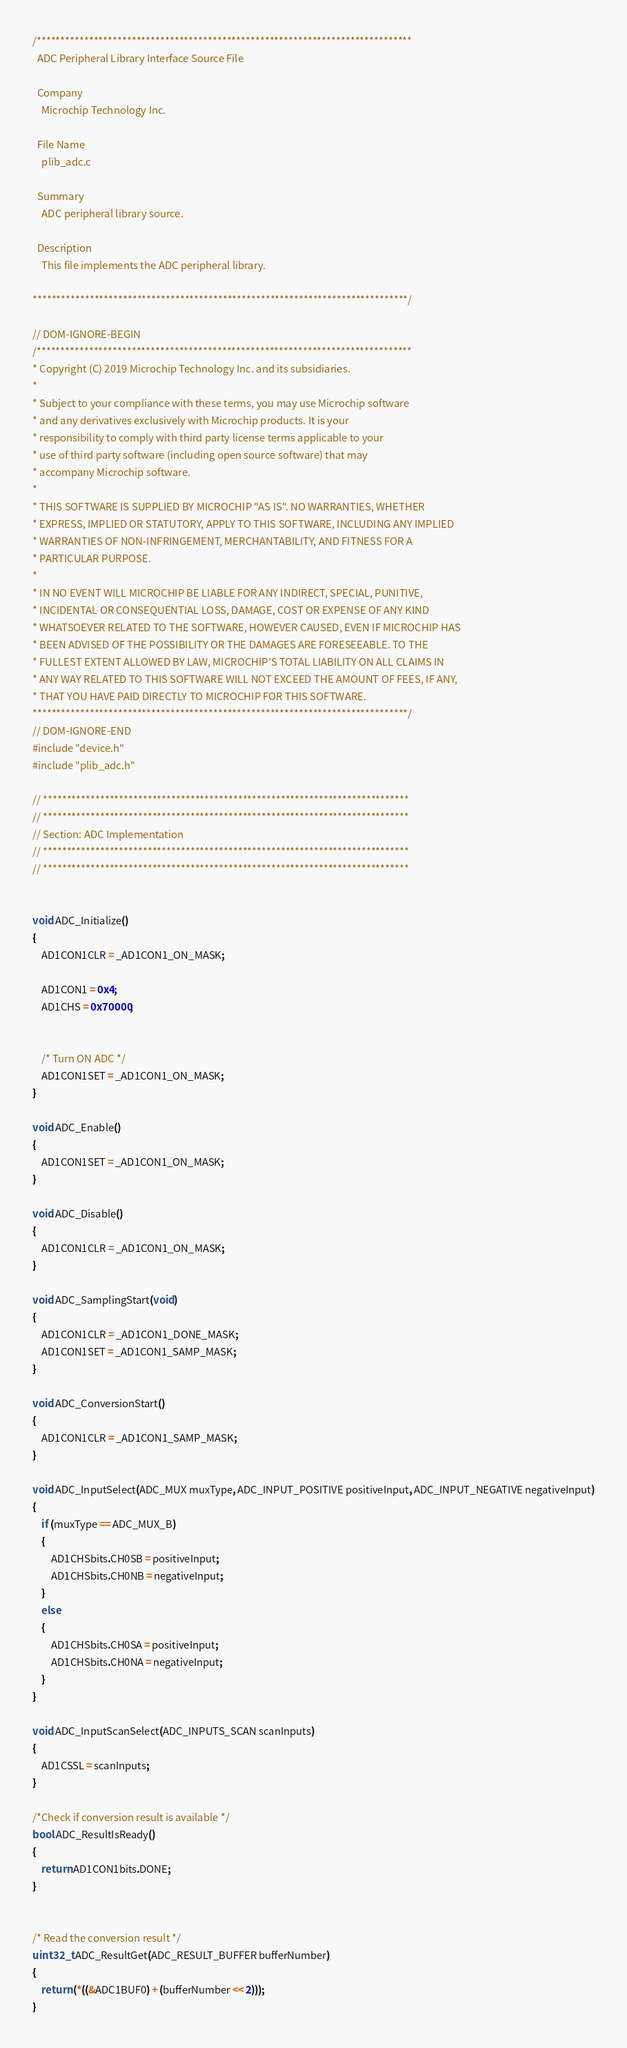Convert code to text. <code><loc_0><loc_0><loc_500><loc_500><_C_>/*******************************************************************************
  ADC Peripheral Library Interface Source File

  Company
    Microchip Technology Inc.

  File Name
    plib_adc.c

  Summary
    ADC peripheral library source.

  Description
    This file implements the ADC peripheral library.

*******************************************************************************/

// DOM-IGNORE-BEGIN
/*******************************************************************************
* Copyright (C) 2019 Microchip Technology Inc. and its subsidiaries.
*
* Subject to your compliance with these terms, you may use Microchip software
* and any derivatives exclusively with Microchip products. It is your
* responsibility to comply with third party license terms applicable to your
* use of third party software (including open source software) that may
* accompany Microchip software.
*
* THIS SOFTWARE IS SUPPLIED BY MICROCHIP "AS IS". NO WARRANTIES, WHETHER
* EXPRESS, IMPLIED OR STATUTORY, APPLY TO THIS SOFTWARE, INCLUDING ANY IMPLIED
* WARRANTIES OF NON-INFRINGEMENT, MERCHANTABILITY, AND FITNESS FOR A
* PARTICULAR PURPOSE.
*
* IN NO EVENT WILL MICROCHIP BE LIABLE FOR ANY INDIRECT, SPECIAL, PUNITIVE,
* INCIDENTAL OR CONSEQUENTIAL LOSS, DAMAGE, COST OR EXPENSE OF ANY KIND
* WHATSOEVER RELATED TO THE SOFTWARE, HOWEVER CAUSED, EVEN IF MICROCHIP HAS
* BEEN ADVISED OF THE POSSIBILITY OR THE DAMAGES ARE FORESEEABLE. TO THE
* FULLEST EXTENT ALLOWED BY LAW, MICROCHIP'S TOTAL LIABILITY ON ALL CLAIMS IN
* ANY WAY RELATED TO THIS SOFTWARE WILL NOT EXCEED THE AMOUNT OF FEES, IF ANY,
* THAT YOU HAVE PAID DIRECTLY TO MICROCHIP FOR THIS SOFTWARE.
*******************************************************************************/
// DOM-IGNORE-END
#include "device.h"
#include "plib_adc.h"

// *****************************************************************************
// *****************************************************************************
// Section: ADC Implementation
// *****************************************************************************
// *****************************************************************************


void ADC_Initialize()
{
    AD1CON1CLR = _AD1CON1_ON_MASK;

    AD1CON1 = 0x4;
    AD1CHS = 0x70000;


    /* Turn ON ADC */
    AD1CON1SET = _AD1CON1_ON_MASK;
}

void ADC_Enable()
{
    AD1CON1SET = _AD1CON1_ON_MASK;
}

void ADC_Disable()
{
    AD1CON1CLR = _AD1CON1_ON_MASK;
}

void ADC_SamplingStart(void)
{
    AD1CON1CLR = _AD1CON1_DONE_MASK;
    AD1CON1SET = _AD1CON1_SAMP_MASK;
}

void ADC_ConversionStart()
{
    AD1CON1CLR = _AD1CON1_SAMP_MASK;
}

void ADC_InputSelect(ADC_MUX muxType, ADC_INPUT_POSITIVE positiveInput, ADC_INPUT_NEGATIVE negativeInput)
{
	if (muxType == ADC_MUX_B)
	{
    	AD1CHSbits.CH0SB = positiveInput;
        AD1CHSbits.CH0NB = negativeInput;
	}
	else
	{
    	AD1CHSbits.CH0SA = positiveInput;
        AD1CHSbits.CH0NA = negativeInput;
	}
}

void ADC_InputScanSelect(ADC_INPUTS_SCAN scanInputs)
{
    AD1CSSL = scanInputs;
}

/*Check if conversion result is available */
bool ADC_ResultIsReady()
{
    return AD1CON1bits.DONE;
}


/* Read the conversion result */
uint32_t ADC_ResultGet(ADC_RESULT_BUFFER bufferNumber)
{
    return (*((&ADC1BUF0) + (bufferNumber << 2)));
}

</code> 